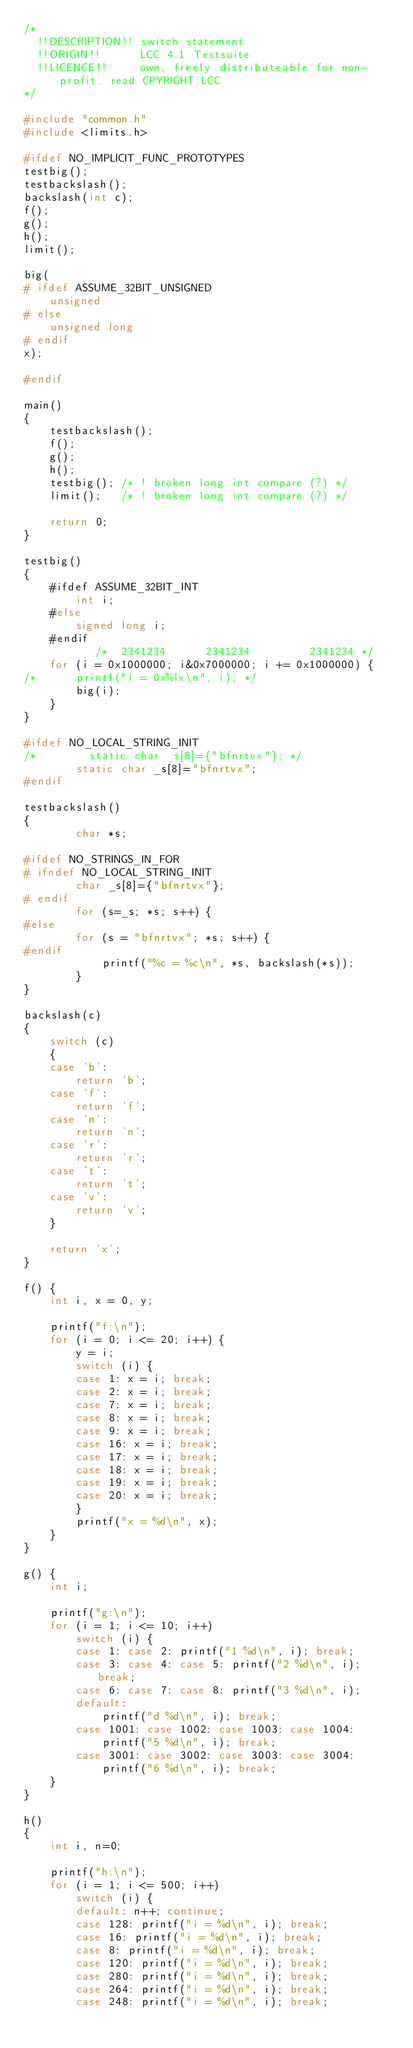Convert code to text. <code><loc_0><loc_0><loc_500><loc_500><_C_>/*
  !!DESCRIPTION!! switch statement
  !!ORIGIN!!      LCC 4.1 Testsuite
  !!LICENCE!!     own, freely distributeable for non-profit. read CPYRIGHT.LCC
*/

#include "common.h"
#include <limits.h>

#ifdef NO_IMPLICIT_FUNC_PROTOTYPES
testbig();
testbackslash();
backslash(int c);
f();
g();
h();
limit();

big(
# ifdef ASSUME_32BIT_UNSIGNED
	unsigned
# else
	unsigned long
# endif
x);

#endif

main()
{
	testbackslash();
	f();
	g();
	h();
	testbig(); /* ! broken long int compare (?) */
	limit();   /* ! broken long int compare (?) */

	return 0;
}

testbig()
{
	#ifdef ASSUME_32BIT_INT
    	int i;
	#else
		signed long i;
	#endif
	       /*  2341234      2341234         2341234 */
	for (i = 0x1000000; i&0x7000000; i += 0x1000000) {
/*		printf("i = 0x%lx\n", i); */
		big(i);
	}
}

#ifdef NO_LOCAL_STRING_INIT
/*        static char _s[8]={"bfnrtvx"}; */
        static char _s[8]="bfnrtvx";
#endif

testbackslash()
{
        char *s;

#ifdef NO_STRINGS_IN_FOR
# ifndef NO_LOCAL_STRING_INIT
        char _s[8]={"bfnrtvx"};
# endif
        for (s=_s; *s; s++) {
#else
        for (s = "bfnrtvx"; *s; s++) {
#endif
			printf("%c = %c\n", *s, backslash(*s));
        }
}

backslash(c)
{
	switch (c)
    {
	case 'b':
		return 'b';
	case 'f':
		return 'f';
	case 'n':
		return 'n';
	case 'r':
		return 'r';
	case 't':
		return 't';
	case 'v':
        return 'v';
	}

	return 'x';
}

f() {
	int i, x = 0, y;

	printf("f:\n");
	for (i = 0; i <= 20; i++) {
		y = i;
		switch (i) {
		case 1: x = i; break;
		case 2: x = i; break;
		case 7: x = i; break;
		case 8: x = i; break;
		case 9: x = i; break;
		case 16: x = i; break;
		case 17: x = i; break;
		case 18: x = i; break;
		case 19: x = i; break;
		case 20: x = i; break;
		}
		printf("x = %d\n", x);
	}
}

g() {
	int i;

	printf("g:\n");
	for (i = 1; i <= 10; i++)
		switch (i) {
		case 1: case 2: printf("1 %d\n", i); break;
		case 3: case 4: case 5: printf("2 %d\n", i); break;
		case 6: case 7: case 8: printf("3 %d\n", i);
		default:
			printf("d %d\n", i); break;
		case 1001: case 1002: case 1003: case 1004:
			printf("5 %d\n", i); break;
		case 3001: case 3002: case 3003: case 3004:
			printf("6 %d\n", i); break;
	}
}

h()
{
	int i, n=0;

	printf("h:\n");
	for (i = 1; i <= 500; i++)
		switch (i) {
		default: n++; continue;
		case 128: printf("i = %d\n", i); break;
		case 16: printf("i = %d\n", i); break;
		case 8: printf("i = %d\n", i); break;
		case 120: printf("i = %d\n", i); break;
		case 280: printf("i = %d\n", i); break;
		case 264: printf("i = %d\n", i); break;
		case 248: printf("i = %d\n", i); break;</code> 